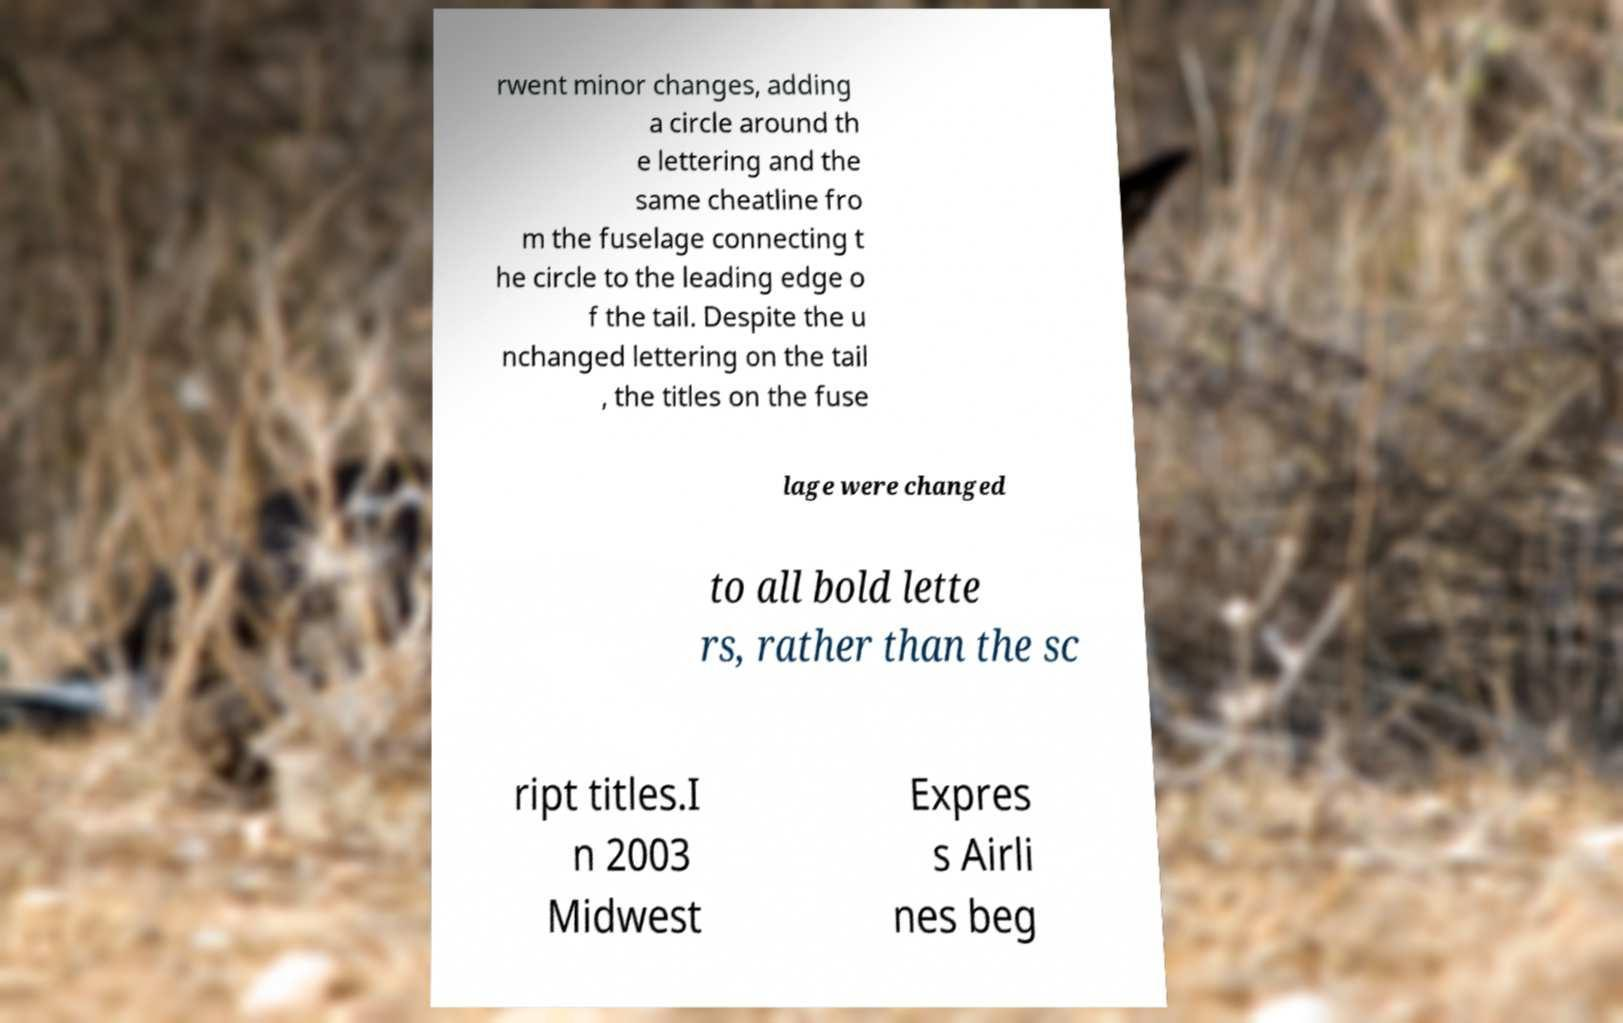Can you accurately transcribe the text from the provided image for me? rwent minor changes, adding a circle around th e lettering and the same cheatline fro m the fuselage connecting t he circle to the leading edge o f the tail. Despite the u nchanged lettering on the tail , the titles on the fuse lage were changed to all bold lette rs, rather than the sc ript titles.I n 2003 Midwest Expres s Airli nes beg 